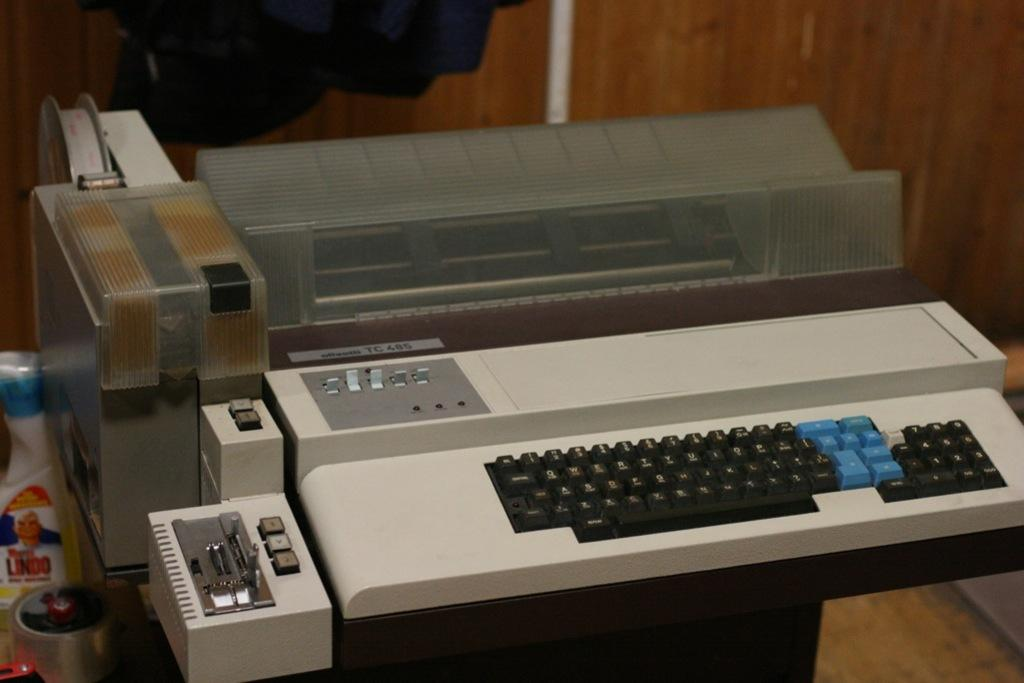What is the main object in the picture? There is a typewriter in the picture. Can you describe any other objects present in the image? Unfortunately, the provided facts only mention that there are other objects in the picture, but no specific details are given. What type of cushion is being used to support the produce in the image? There is no cushion or produce present in the image; it only features a typewriter. 